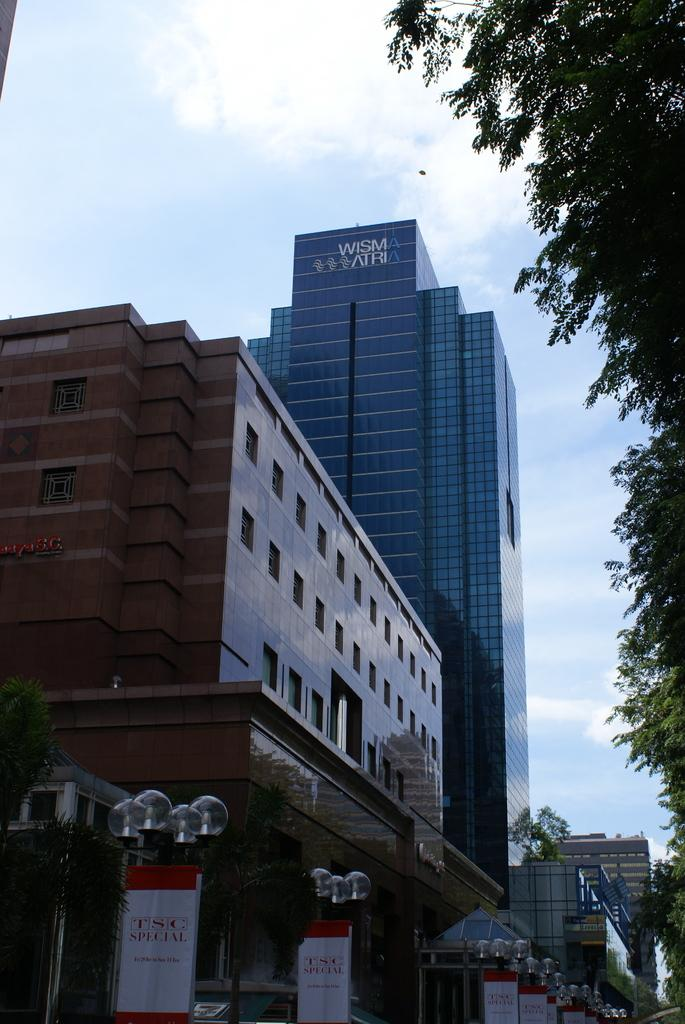<image>
Provide a brief description of the given image. TSC Special banners are displayed on a street, where you can also see the side of the Wisma Atria building. 